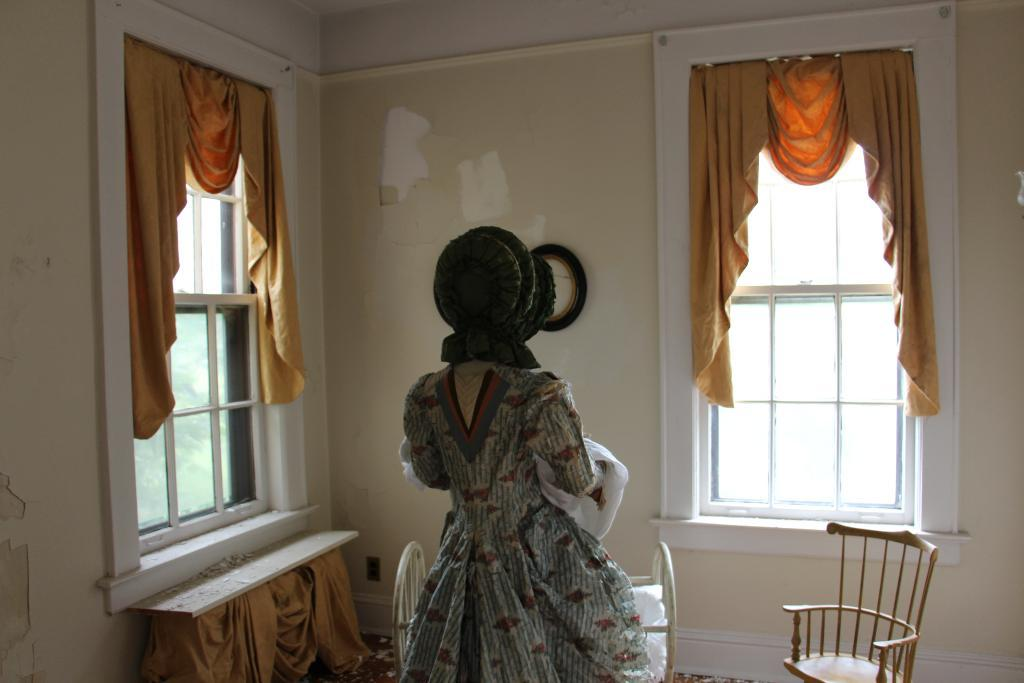What type of window coverings are present in the image? There are curtains on the windows in the image. What type of furniture is on the floor in the image? There are chairs on the floor in the image. Can you describe the person in the image? One person is standing in the image. How many legs does the pear have in the image? There is no pear present in the image, so it is not possible to determine the number of legs it might have. 